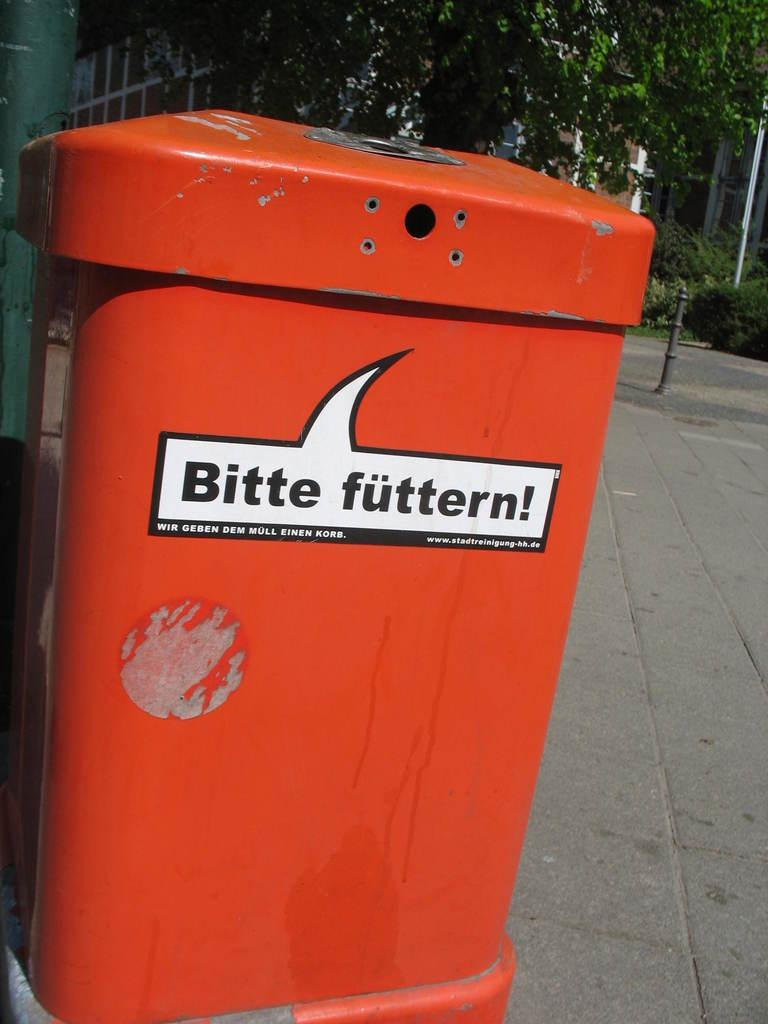<image>
Summarize the visual content of the image. An orange container on the street reads Bitte futtern! 